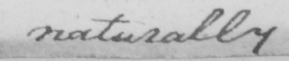What does this handwritten line say? naturally 